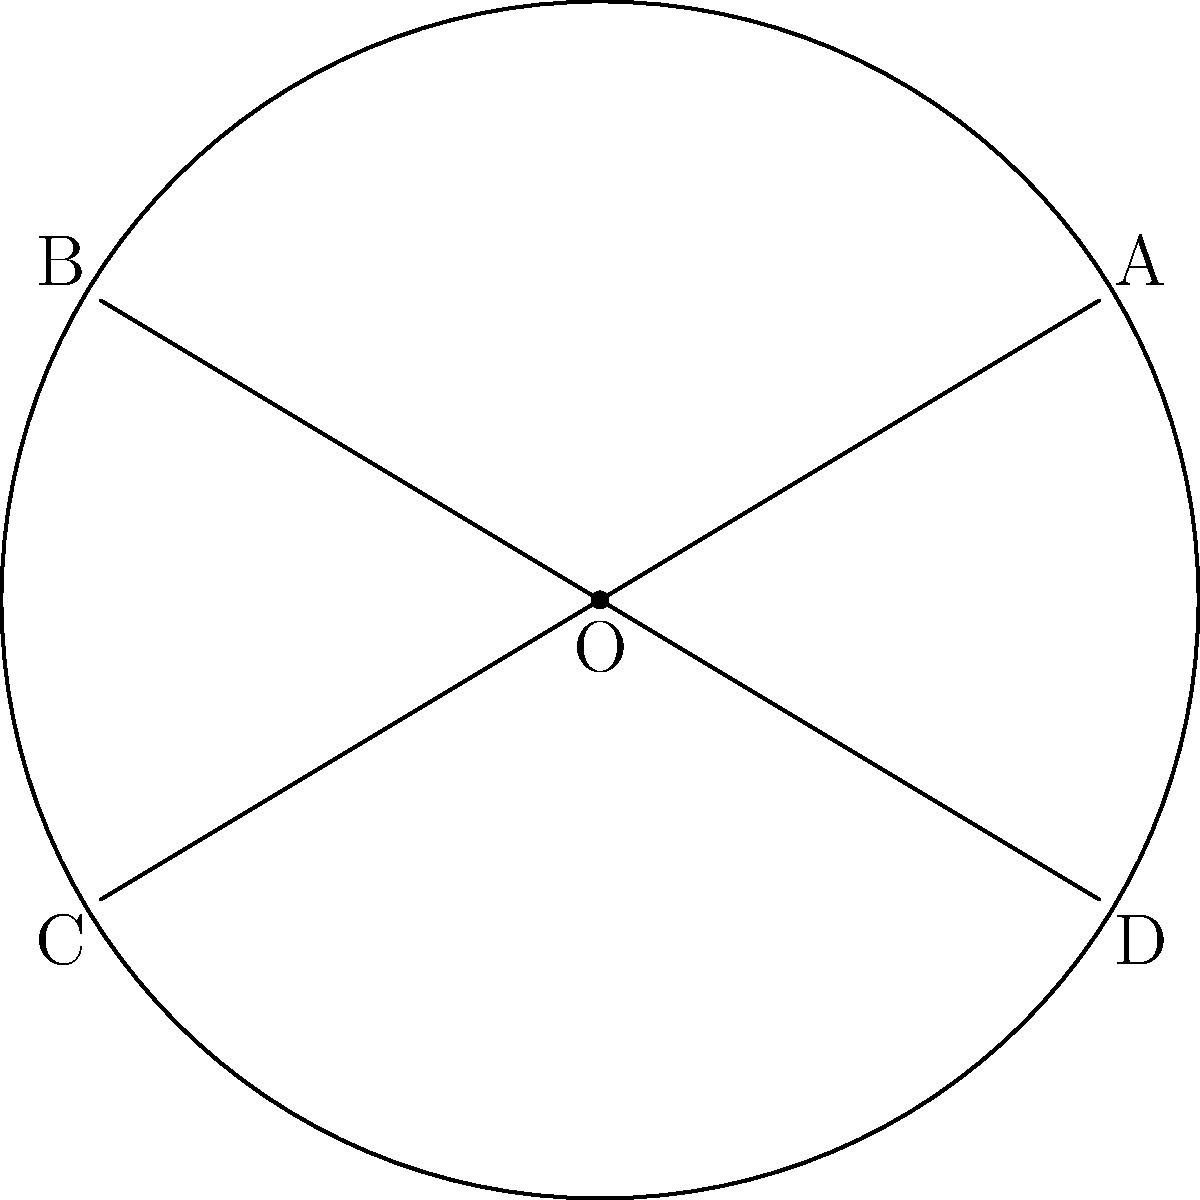In your circular garden bed with a radius of 6 meters, you've designed two intersecting pathways that form chords AB and CD, as shown in the diagram. If the distance between the midpoints of these chords is 4 meters, what is the area of the garden bed that remains unoccupied by the pathways? Assume the pathways have negligible width. Let's approach this step-by-step:

1) First, we need to find the length of the chords AB and CD. We can do this using the formula for the distance between chord midpoints:

   $$d^2 = 4R^2 - (a^2 + b^2)$$

   Where $d$ is the distance between midpoints, $R$ is the radius, and $a$ and $b$ are the lengths of the chords.

2) We know $d = 4$ and $R = 6$. Let's assume both chords have the same length $x$. Substituting into the formula:

   $$4^2 = 4(6^2) - (x^2 + x^2)$$
   $$16 = 144 - 2x^2$$
   $$2x^2 = 128$$
   $$x^2 = 64$$
   $$x = 8$$

3) Now that we know the chord length, we can find the area of the segments cut off by these chords. The formula for a segment area is:

   $$A_{segment} = R^2 \arccos(\frac{x}{2R}) - \frac{x}{2}\sqrt{R^2 - (\frac{x}{2})^2}$$

4) Substituting our values:

   $$A_{segment} = 6^2 \arccos(\frac{8}{2(6)}) - \frac{8}{2}\sqrt{6^2 - (\frac{8}{2})^2}$$
   $$= 36 \arccos(\frac{2}{3}) - 4\sqrt{36 - 16}$$
   $$= 36 \arccos(\frac{2}{3}) - 4\sqrt{20}$$

5) There are four such segments in total. The area of the garden bed occupied by pathways is four times this value:

   $$A_{occupied} = 4(36 \arccos(\frac{2}{3}) - 4\sqrt{20})$$

6) The total area of the circular garden bed is $\pi R^2 = 36\pi$.

7) Therefore, the unoccupied area is:

   $$A_{unoccupied} = 36\pi - 4(36 \arccos(\frac{2}{3}) - 4\sqrt{20})$$

8) Simplifying:

   $$A_{unoccupied} = 36\pi - 144 \arccos(\frac{2}{3}) + 16\sqrt{20}$$
Answer: $36\pi - 144 \arccos(\frac{2}{3}) + 16\sqrt{20}$ square meters 